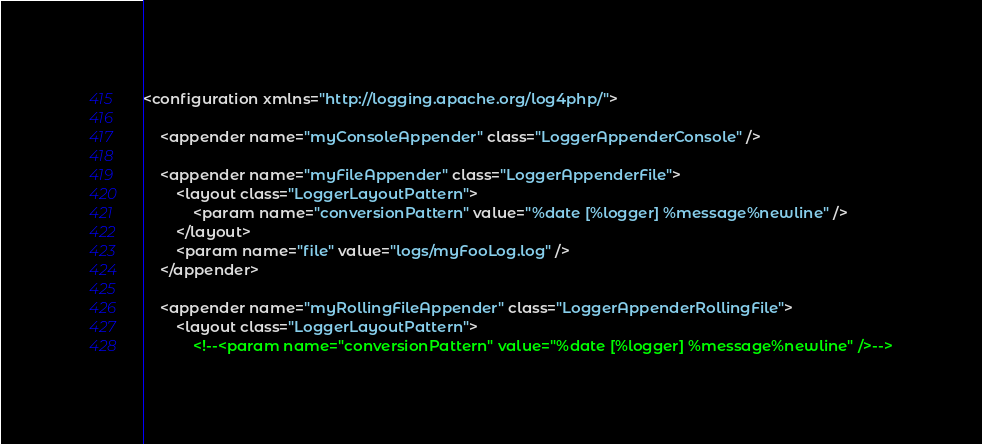<code> <loc_0><loc_0><loc_500><loc_500><_XML_><configuration xmlns="http://logging.apache.org/log4php/">

    <appender name="myConsoleAppender" class="LoggerAppenderConsole" />

    <appender name="myFileAppender" class="LoggerAppenderFile">
        <layout class="LoggerLayoutPattern">
            <param name="conversionPattern" value="%date [%logger] %message%newline" />
        </layout>
        <param name="file" value="logs/myFooLog.log" />
    </appender>

    <appender name="myRollingFileAppender" class="LoggerAppenderRollingFile">
        <layout class="LoggerLayoutPattern">
            <!--<param name="conversionPattern" value="%date [%logger] %message%newline" />--></code> 